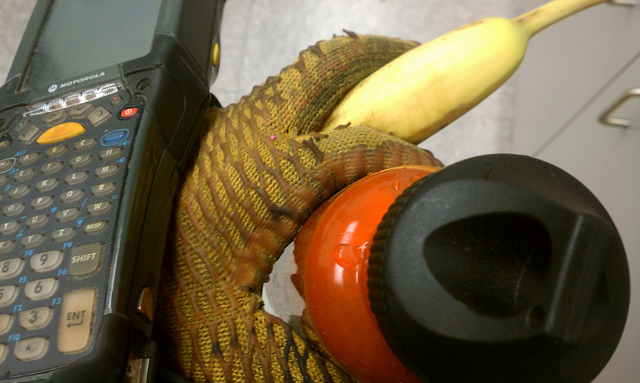Read all the text in this image. ENT SHIFT MOTOROLA 8 6 